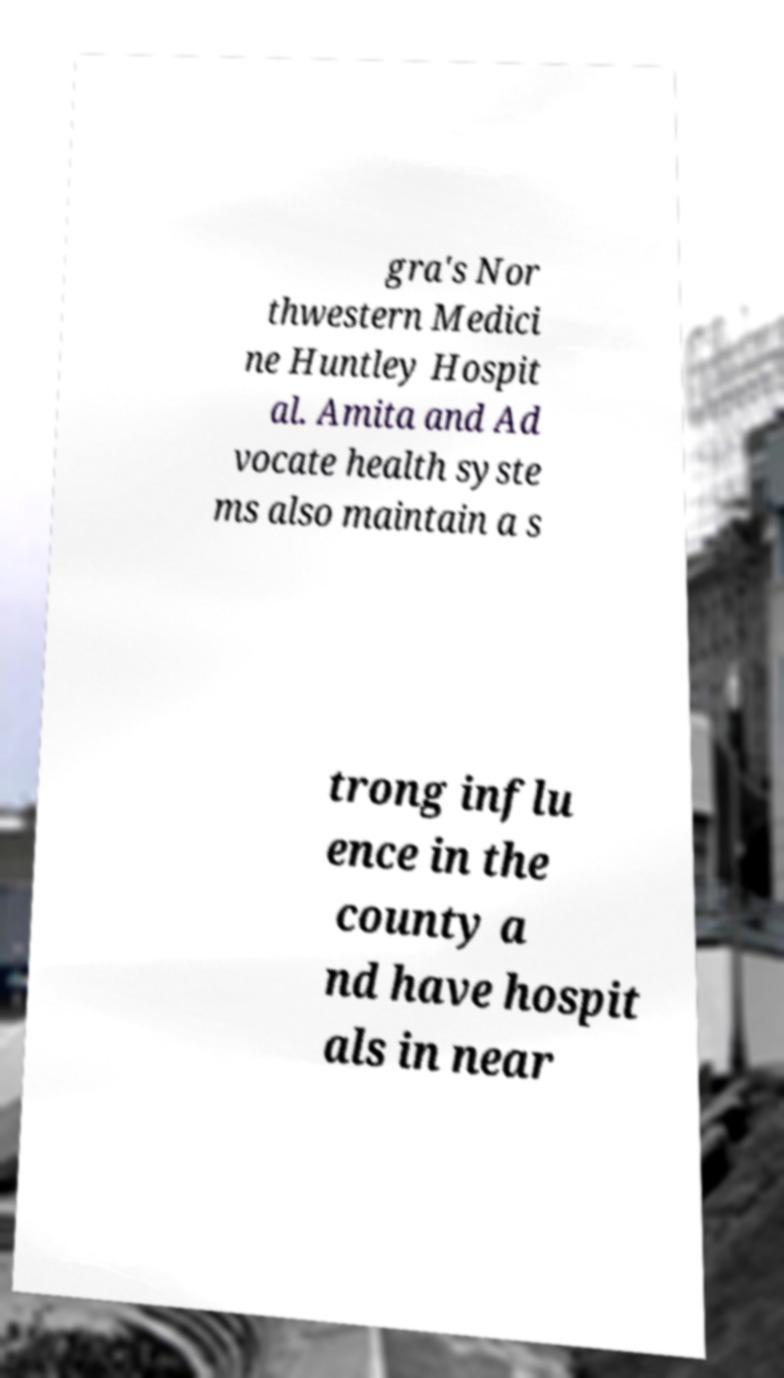There's text embedded in this image that I need extracted. Can you transcribe it verbatim? gra's Nor thwestern Medici ne Huntley Hospit al. Amita and Ad vocate health syste ms also maintain a s trong influ ence in the county a nd have hospit als in near 